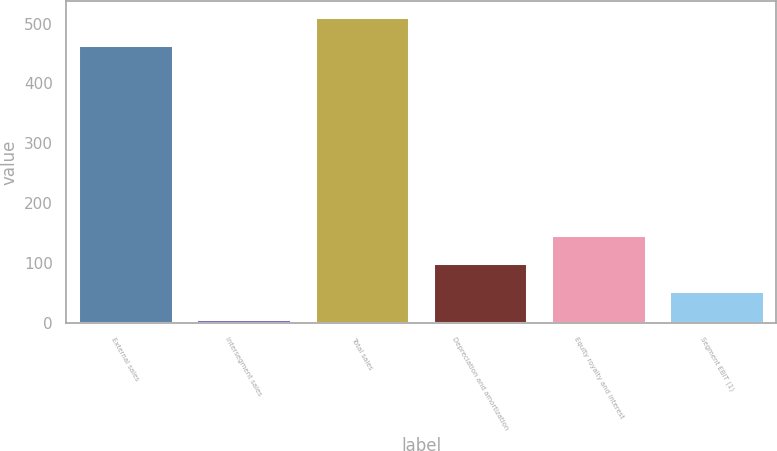Convert chart. <chart><loc_0><loc_0><loc_500><loc_500><bar_chart><fcel>External sales<fcel>Intersegment sales<fcel>Total sales<fcel>Depreciation and amortization<fcel>Equity royalty and interest<fcel>Segment EBIT (1)<nl><fcel>465<fcel>7<fcel>511.5<fcel>100<fcel>146.5<fcel>53.5<nl></chart> 